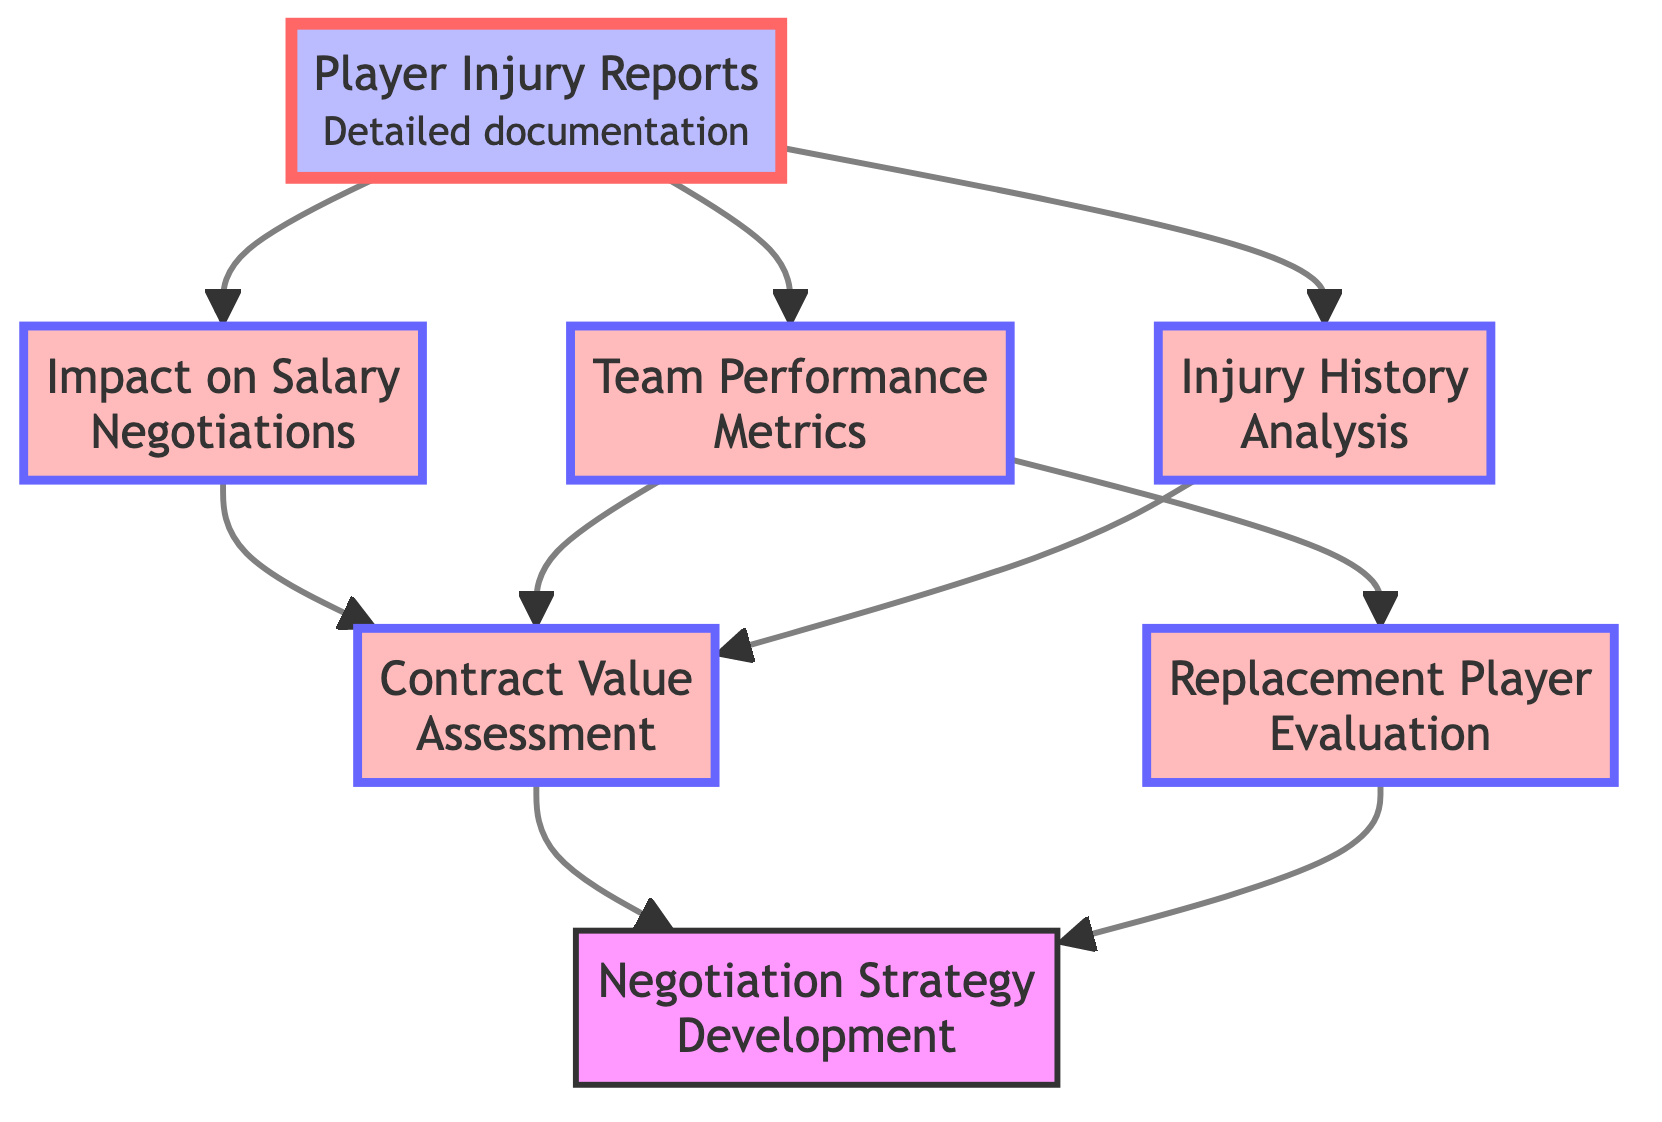What is the first node in the diagram? The first node, or starting point, is "Player Injury Reports," which serves as the foundation for analyzing player injuries.
Answer: Player Injury Reports How many total nodes are present in the diagram? By counting each individual element represented in the diagram, we find that there are a total of 7 nodes: Player Injury Reports, Impact on Salary Negotiations, Team Performance Metrics, Injury History Analysis, Contract Value Assessment, Replacement Player Evaluation, and Negotiation Strategy Development.
Answer: 7 Which node connects to the 'Contract Value Assessment' node? The nodes that feed into the 'Contract Value Assessment' node are 'Impact on Salary Negotiations,' 'Team Performance Metrics,' and 'Injury History Analysis,' indicating that this evaluation considers multiple factors.
Answer: Impact on Salary Negotiations, Team Performance Metrics, Injury History Analysis What is the last node in the flowchart? The last node, which is the culmination of the analysis process, is "Negotiation Strategy Development," representing the outcome of all previous evaluations.
Answer: Negotiation Strategy Development Which node is directly influenced by 'Team Performance Metrics'? The node that is directly influenced by 'Team Performance Metrics' is 'Replacement Player Evaluation,' indicating that team performance data affects the assessment of replacement players.
Answer: Replacement Player Evaluation How many relationships connect the 'Player Injury Reports' node to other nodes? The 'Player Injury Reports' node connects to three other nodes, specifically to 'Impact on Salary Negotiations,' 'Team Performance Metrics,' and 'Injury History Analysis,' showing its central role in the evaluation process.
Answer: 3 What is the primary purpose of the 'Negotiation Strategy Development' node? The primary purpose of this node is to create a strategy for contract negotiations based on insights derived from player injury data and its implications on salary and performance.
Answer: Strategy for contract negotiations How does the 'Injury History Analysis' influence the rest of the diagram? 'Injury History Analysis' feeds into the 'Contract Value Assessment' node, emphasizing its role in evaluating the overall value of player contracts based on injury risk.
Answer: Influences contract value assessment 